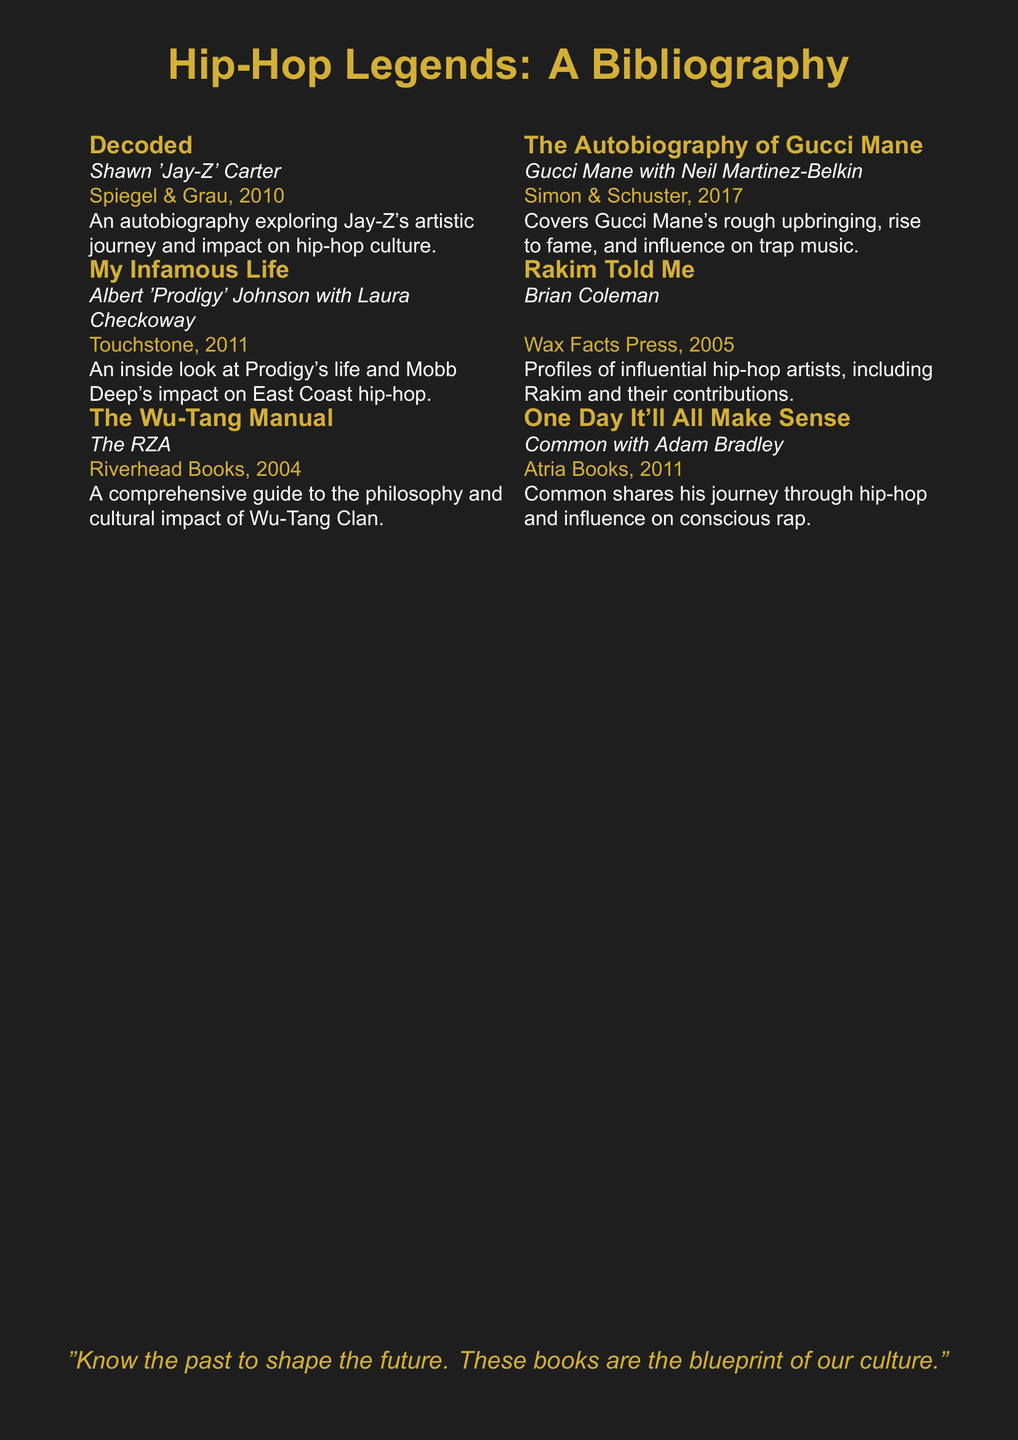what is the title of Jay-Z's autobiography? The document lists "Decoded" as the title of Jay-Z's autobiography.
Answer: Decoded who authored "The Autobiography of Gucci Mane"? The document states that "The Autobiography of Gucci Mane" was authored by Gucci Mane with Neil Martinez-Belkin.
Answer: Gucci Mane with Neil Martinez-Belkin which publisher released "My Infamous Life"? According to the document, "My Infamous Life" was published by Touchstone.
Answer: Touchstone what is the main focus of "The Wu-Tang Manual"? The document indicates that "The Wu-Tang Manual" is a comprehensive guide to the philosophy and cultural impact of Wu-Tang Clan.
Answer: Philosophy and cultural impact of Wu-Tang Clan how many books are listed in the bibliography? The document presents a total of 6 books listed in the bibliography.
Answer: 6 who is the author of "One Day It'll All Make Sense"? The author of "One Day It'll All Make Sense" is Common with Adam Bradley, as stated in the document.
Answer: Common with Adam Bradley which book discusses the influence on conscious rap? The document specifies that "One Day It'll All Make Sense" shares Common's journey and influence on conscious rap.
Answer: One Day It'll All Make Sense when was "Decoded" published? The document states that "Decoded" was published in 2010.
Answer: 2010 what genre does "The Autobiography of Gucci Mane" primarily focus on? The document indicates that "The Autobiography of Gucci Mane" focuses on trap music.
Answer: Trap music 